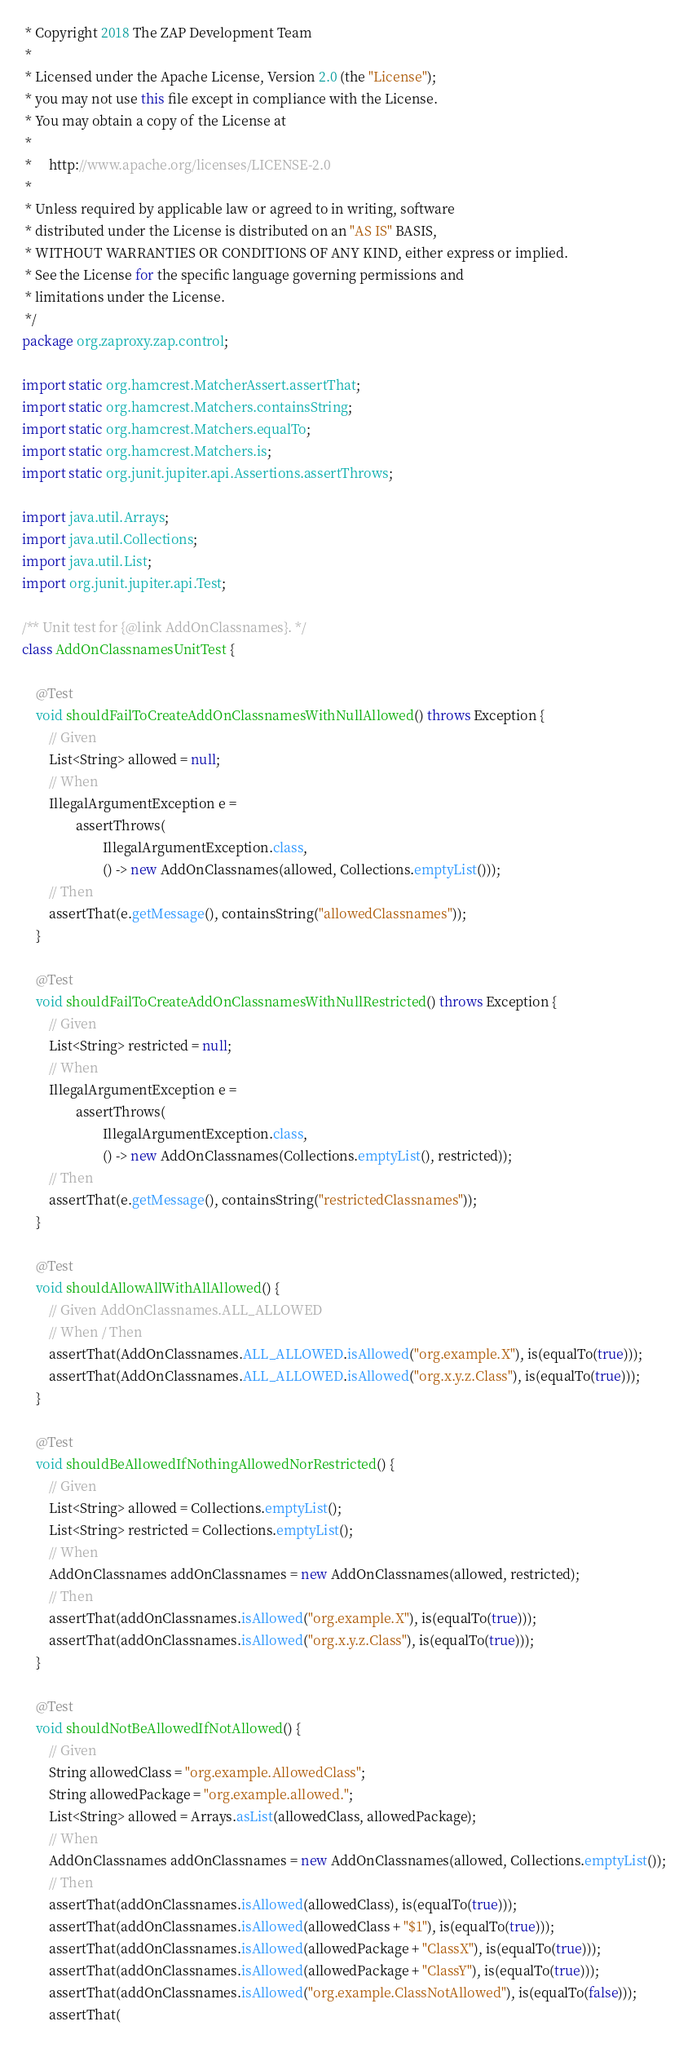Convert code to text. <code><loc_0><loc_0><loc_500><loc_500><_Java_> * Copyright 2018 The ZAP Development Team
 *
 * Licensed under the Apache License, Version 2.0 (the "License");
 * you may not use this file except in compliance with the License.
 * You may obtain a copy of the License at
 *
 *     http://www.apache.org/licenses/LICENSE-2.0
 *
 * Unless required by applicable law or agreed to in writing, software
 * distributed under the License is distributed on an "AS IS" BASIS,
 * WITHOUT WARRANTIES OR CONDITIONS OF ANY KIND, either express or implied.
 * See the License for the specific language governing permissions and
 * limitations under the License.
 */
package org.zaproxy.zap.control;

import static org.hamcrest.MatcherAssert.assertThat;
import static org.hamcrest.Matchers.containsString;
import static org.hamcrest.Matchers.equalTo;
import static org.hamcrest.Matchers.is;
import static org.junit.jupiter.api.Assertions.assertThrows;

import java.util.Arrays;
import java.util.Collections;
import java.util.List;
import org.junit.jupiter.api.Test;

/** Unit test for {@link AddOnClassnames}. */
class AddOnClassnamesUnitTest {

    @Test
    void shouldFailToCreateAddOnClassnamesWithNullAllowed() throws Exception {
        // Given
        List<String> allowed = null;
        // When
        IllegalArgumentException e =
                assertThrows(
                        IllegalArgumentException.class,
                        () -> new AddOnClassnames(allowed, Collections.emptyList()));
        // Then
        assertThat(e.getMessage(), containsString("allowedClassnames"));
    }

    @Test
    void shouldFailToCreateAddOnClassnamesWithNullRestricted() throws Exception {
        // Given
        List<String> restricted = null;
        // When
        IllegalArgumentException e =
                assertThrows(
                        IllegalArgumentException.class,
                        () -> new AddOnClassnames(Collections.emptyList(), restricted));
        // Then
        assertThat(e.getMessage(), containsString("restrictedClassnames"));
    }

    @Test
    void shouldAllowAllWithAllAllowed() {
        // Given AddOnClassnames.ALL_ALLOWED
        // When / Then
        assertThat(AddOnClassnames.ALL_ALLOWED.isAllowed("org.example.X"), is(equalTo(true)));
        assertThat(AddOnClassnames.ALL_ALLOWED.isAllowed("org.x.y.z.Class"), is(equalTo(true)));
    }

    @Test
    void shouldBeAllowedIfNothingAllowedNorRestricted() {
        // Given
        List<String> allowed = Collections.emptyList();
        List<String> restricted = Collections.emptyList();
        // When
        AddOnClassnames addOnClassnames = new AddOnClassnames(allowed, restricted);
        // Then
        assertThat(addOnClassnames.isAllowed("org.example.X"), is(equalTo(true)));
        assertThat(addOnClassnames.isAllowed("org.x.y.z.Class"), is(equalTo(true)));
    }

    @Test
    void shouldNotBeAllowedIfNotAllowed() {
        // Given
        String allowedClass = "org.example.AllowedClass";
        String allowedPackage = "org.example.allowed.";
        List<String> allowed = Arrays.asList(allowedClass, allowedPackage);
        // When
        AddOnClassnames addOnClassnames = new AddOnClassnames(allowed, Collections.emptyList());
        // Then
        assertThat(addOnClassnames.isAllowed(allowedClass), is(equalTo(true)));
        assertThat(addOnClassnames.isAllowed(allowedClass + "$1"), is(equalTo(true)));
        assertThat(addOnClassnames.isAllowed(allowedPackage + "ClassX"), is(equalTo(true)));
        assertThat(addOnClassnames.isAllowed(allowedPackage + "ClassY"), is(equalTo(true)));
        assertThat(addOnClassnames.isAllowed("org.example.ClassNotAllowed"), is(equalTo(false)));
        assertThat(</code> 